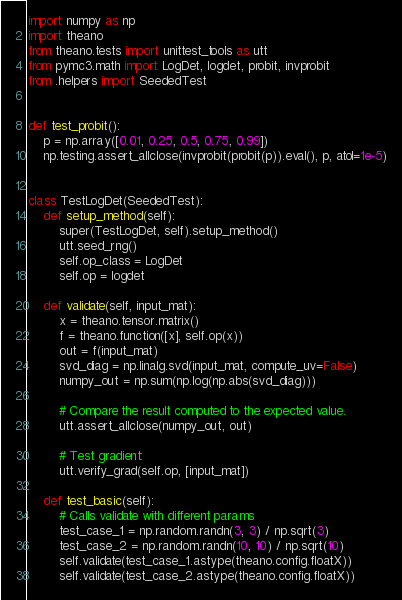<code> <loc_0><loc_0><loc_500><loc_500><_Python_>import numpy as np
import theano
from theano.tests import unittest_tools as utt
from pymc3.math import LogDet, logdet, probit, invprobit
from .helpers import SeededTest


def test_probit():
    p = np.array([0.01, 0.25, 0.5, 0.75, 0.99])
    np.testing.assert_allclose(invprobit(probit(p)).eval(), p, atol=1e-5)


class TestLogDet(SeededTest):
    def setup_method(self):
        super(TestLogDet, self).setup_method()
        utt.seed_rng()
        self.op_class = LogDet
        self.op = logdet

    def validate(self, input_mat):
        x = theano.tensor.matrix()
        f = theano.function([x], self.op(x))
        out = f(input_mat)
        svd_diag = np.linalg.svd(input_mat, compute_uv=False)
        numpy_out = np.sum(np.log(np.abs(svd_diag)))

        # Compare the result computed to the expected value.
        utt.assert_allclose(numpy_out, out)

        # Test gradient:
        utt.verify_grad(self.op, [input_mat])

    def test_basic(self):
        # Calls validate with different params
        test_case_1 = np.random.randn(3, 3) / np.sqrt(3)
        test_case_2 = np.random.randn(10, 10) / np.sqrt(10)
        self.validate(test_case_1.astype(theano.config.floatX))
        self.validate(test_case_2.astype(theano.config.floatX))
</code> 